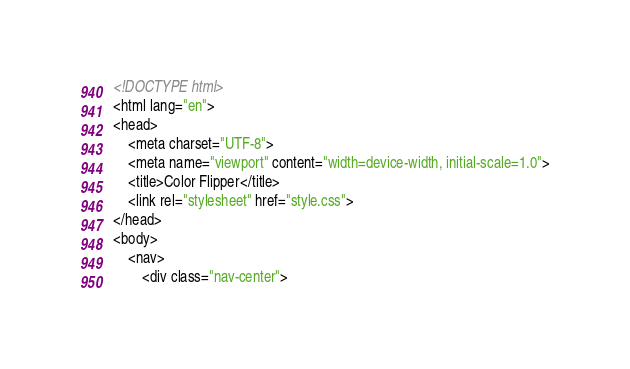<code> <loc_0><loc_0><loc_500><loc_500><_HTML_><!DOCTYPE html>
<html lang="en">
<head>
    <meta charset="UTF-8">
    <meta name="viewport" content="width=device-width, initial-scale=1.0">
    <title>Color Flipper</title>
    <link rel="stylesheet" href="style.css">
</head>
<body>
    <nav>
        <div class="nav-center"></code> 